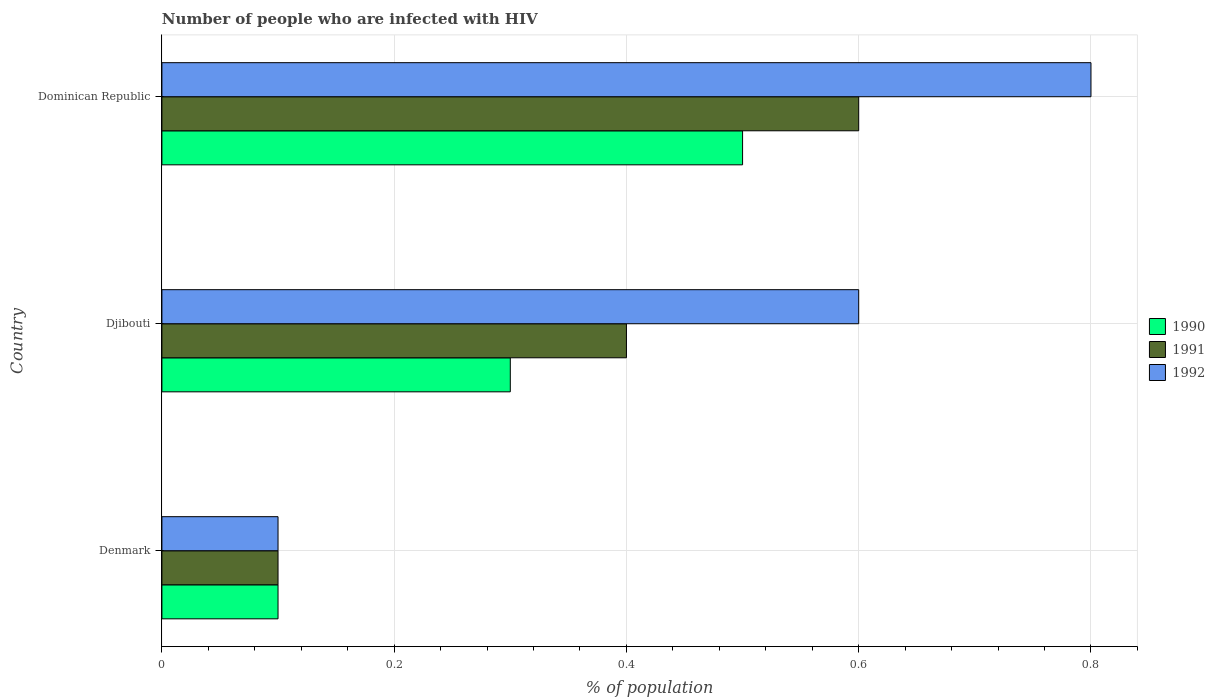Are the number of bars per tick equal to the number of legend labels?
Provide a short and direct response. Yes. Are the number of bars on each tick of the Y-axis equal?
Provide a short and direct response. Yes. What is the label of the 1st group of bars from the top?
Make the answer very short. Dominican Republic. In how many cases, is the number of bars for a given country not equal to the number of legend labels?
Give a very brief answer. 0. What is the percentage of HIV infected population in in 1991 in Denmark?
Your response must be concise. 0.1. Across all countries, what is the maximum percentage of HIV infected population in in 1992?
Your answer should be compact. 0.8. Across all countries, what is the minimum percentage of HIV infected population in in 1990?
Provide a short and direct response. 0.1. In which country was the percentage of HIV infected population in in 1990 maximum?
Give a very brief answer. Dominican Republic. What is the total percentage of HIV infected population in in 1992 in the graph?
Your answer should be very brief. 1.5. What is the difference between the percentage of HIV infected population in in 1992 in Djibouti and that in Dominican Republic?
Your answer should be very brief. -0.2. What is the difference between the percentage of HIV infected population in in 1992 and percentage of HIV infected population in in 1990 in Dominican Republic?
Your response must be concise. 0.3. In how many countries, is the percentage of HIV infected population in in 1992 greater than 0.6000000000000001 %?
Offer a very short reply. 1. What is the ratio of the percentage of HIV infected population in in 1990 in Djibouti to that in Dominican Republic?
Offer a very short reply. 0.6. What is the difference between the highest and the lowest percentage of HIV infected population in in 1991?
Offer a terse response. 0.5. Is the sum of the percentage of HIV infected population in in 1991 in Djibouti and Dominican Republic greater than the maximum percentage of HIV infected population in in 1992 across all countries?
Make the answer very short. Yes. What does the 1st bar from the bottom in Dominican Republic represents?
Ensure brevity in your answer.  1990. Are all the bars in the graph horizontal?
Provide a succinct answer. Yes. How many countries are there in the graph?
Provide a succinct answer. 3. Are the values on the major ticks of X-axis written in scientific E-notation?
Give a very brief answer. No. Does the graph contain any zero values?
Ensure brevity in your answer.  No. How are the legend labels stacked?
Ensure brevity in your answer.  Vertical. What is the title of the graph?
Provide a short and direct response. Number of people who are infected with HIV. Does "1965" appear as one of the legend labels in the graph?
Ensure brevity in your answer.  No. What is the label or title of the X-axis?
Provide a short and direct response. % of population. What is the % of population in 1991 in Djibouti?
Give a very brief answer. 0.4. What is the % of population in 1992 in Djibouti?
Make the answer very short. 0.6. What is the % of population of 1990 in Dominican Republic?
Give a very brief answer. 0.5. What is the % of population in 1991 in Dominican Republic?
Provide a succinct answer. 0.6. What is the % of population of 1992 in Dominican Republic?
Offer a very short reply. 0.8. Across all countries, what is the maximum % of population of 1991?
Your answer should be very brief. 0.6. Across all countries, what is the minimum % of population of 1990?
Your answer should be very brief. 0.1. Across all countries, what is the minimum % of population of 1991?
Your answer should be very brief. 0.1. What is the total % of population in 1990 in the graph?
Make the answer very short. 0.9. What is the total % of population of 1991 in the graph?
Ensure brevity in your answer.  1.1. What is the difference between the % of population of 1991 in Denmark and that in Dominican Republic?
Ensure brevity in your answer.  -0.5. What is the difference between the % of population of 1990 in Denmark and the % of population of 1991 in Djibouti?
Provide a succinct answer. -0.3. What is the difference between the % of population in 1990 in Denmark and the % of population in 1992 in Djibouti?
Give a very brief answer. -0.5. What is the difference between the % of population of 1990 in Denmark and the % of population of 1991 in Dominican Republic?
Keep it short and to the point. -0.5. What is the difference between the % of population of 1990 in Denmark and the % of population of 1992 in Dominican Republic?
Provide a short and direct response. -0.7. What is the difference between the % of population in 1991 in Denmark and the % of population in 1992 in Dominican Republic?
Make the answer very short. -0.7. What is the difference between the % of population in 1990 in Djibouti and the % of population in 1991 in Dominican Republic?
Make the answer very short. -0.3. What is the difference between the % of population in 1990 in Djibouti and the % of population in 1992 in Dominican Republic?
Ensure brevity in your answer.  -0.5. What is the average % of population in 1990 per country?
Keep it short and to the point. 0.3. What is the average % of population of 1991 per country?
Make the answer very short. 0.37. What is the average % of population in 1992 per country?
Offer a terse response. 0.5. What is the difference between the % of population in 1990 and % of population in 1992 in Denmark?
Provide a succinct answer. 0. What is the difference between the % of population in 1991 and % of population in 1992 in Denmark?
Provide a succinct answer. 0. What is the difference between the % of population in 1990 and % of population in 1991 in Djibouti?
Your answer should be compact. -0.1. What is the ratio of the % of population in 1992 in Denmark to that in Djibouti?
Give a very brief answer. 0.17. What is the ratio of the % of population in 1990 in Denmark to that in Dominican Republic?
Ensure brevity in your answer.  0.2. What is the ratio of the % of population in 1990 in Djibouti to that in Dominican Republic?
Offer a terse response. 0.6. What is the ratio of the % of population of 1991 in Djibouti to that in Dominican Republic?
Provide a short and direct response. 0.67. What is the difference between the highest and the second highest % of population of 1992?
Your response must be concise. 0.2. What is the difference between the highest and the lowest % of population of 1991?
Your answer should be very brief. 0.5. What is the difference between the highest and the lowest % of population in 1992?
Your answer should be very brief. 0.7. 